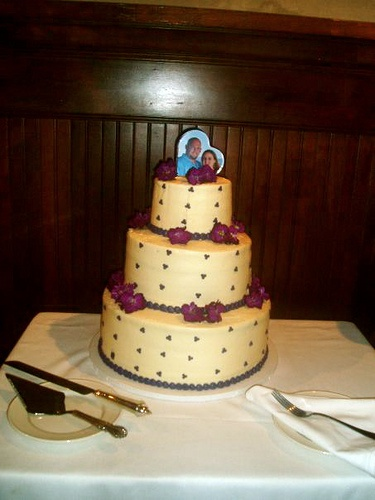Describe the objects in this image and their specific colors. I can see dining table in black, beige, tan, and darkgray tones, cake in black, khaki, tan, and maroon tones, knife in black, olive, maroon, and tan tones, fork in black, lightgray, darkgray, and gray tones, and people in black, lightblue, brown, gray, and teal tones in this image. 